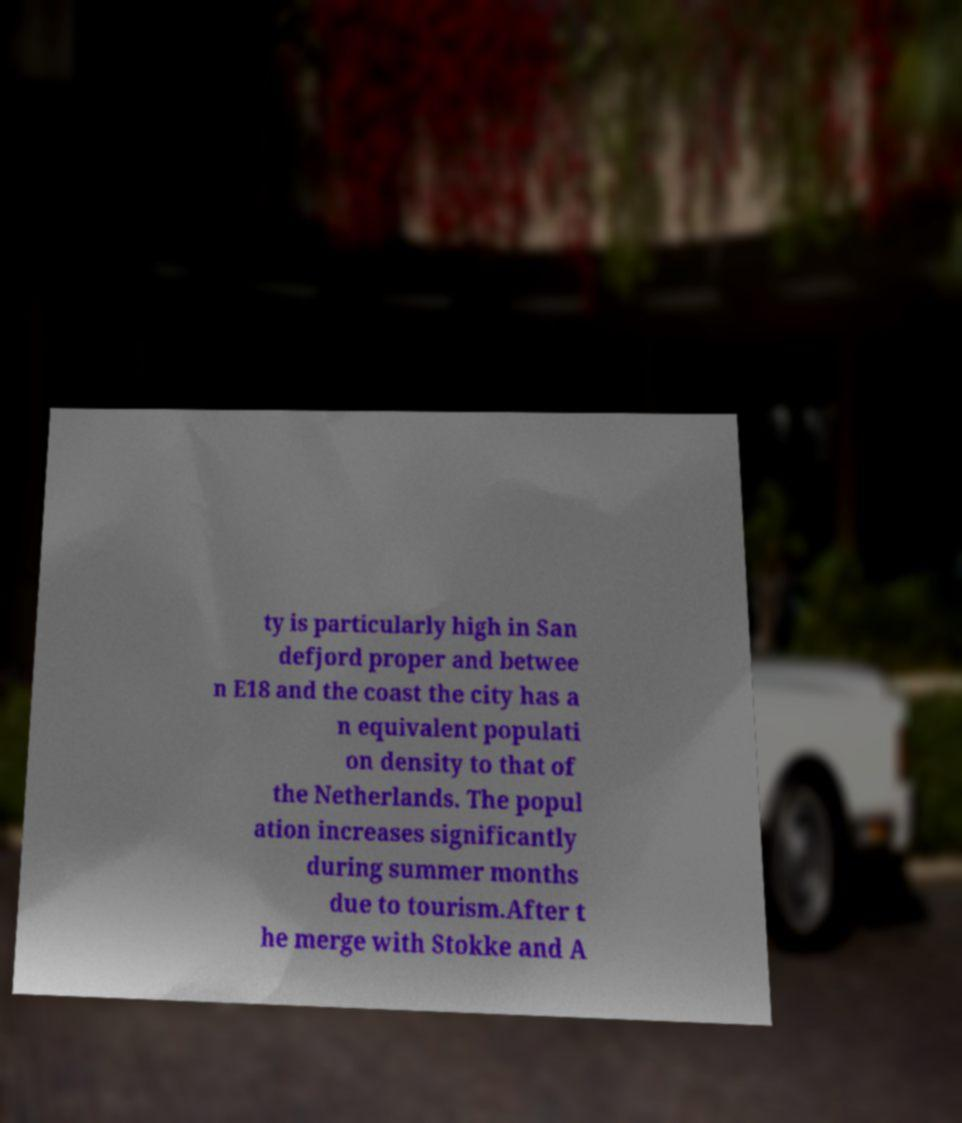Please identify and transcribe the text found in this image. ty is particularly high in San defjord proper and betwee n E18 and the coast the city has a n equivalent populati on density to that of the Netherlands. The popul ation increases significantly during summer months due to tourism.After t he merge with Stokke and A 